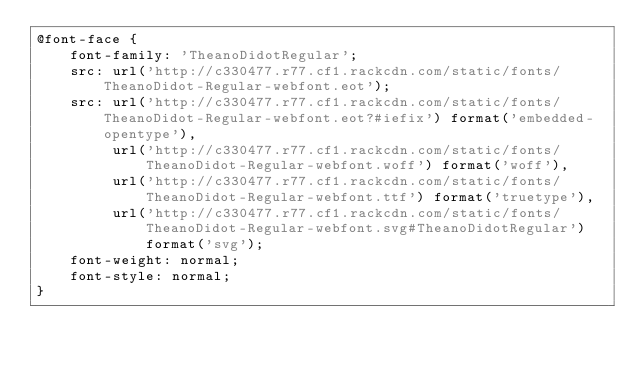Convert code to text. <code><loc_0><loc_0><loc_500><loc_500><_CSS_>@font-face {
    font-family: 'TheanoDidotRegular';
    src: url('http://c330477.r77.cf1.rackcdn.com/static/fonts/TheanoDidot-Regular-webfont.eot');
    src: url('http://c330477.r77.cf1.rackcdn.com/static/fonts/TheanoDidot-Regular-webfont.eot?#iefix') format('embedded-opentype'),
         url('http://c330477.r77.cf1.rackcdn.com/static/fonts/TheanoDidot-Regular-webfont.woff') format('woff'),
         url('http://c330477.r77.cf1.rackcdn.com/static/fonts/TheanoDidot-Regular-webfont.ttf') format('truetype'),
         url('http://c330477.r77.cf1.rackcdn.com/static/fonts/TheanoDidot-Regular-webfont.svg#TheanoDidotRegular') format('svg');
    font-weight: normal;
    font-style: normal;
}
</code> 